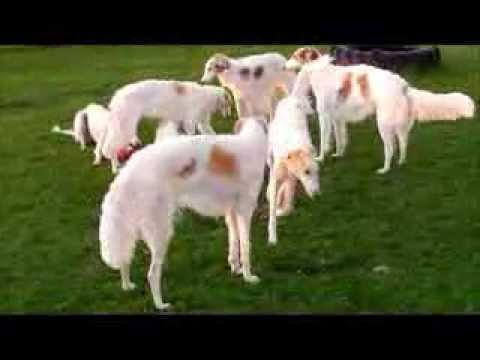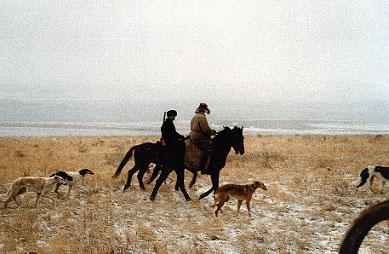The first image is the image on the left, the second image is the image on the right. Given the left and right images, does the statement "A group of dogs is playing outside, and at least two dogs have both front paws off the ground." hold true? Answer yes or no. No. The first image is the image on the left, the second image is the image on the right. Examine the images to the left and right. Is the description "At least one person is outside with the dogs in the image on the right." accurate? Answer yes or no. Yes. 